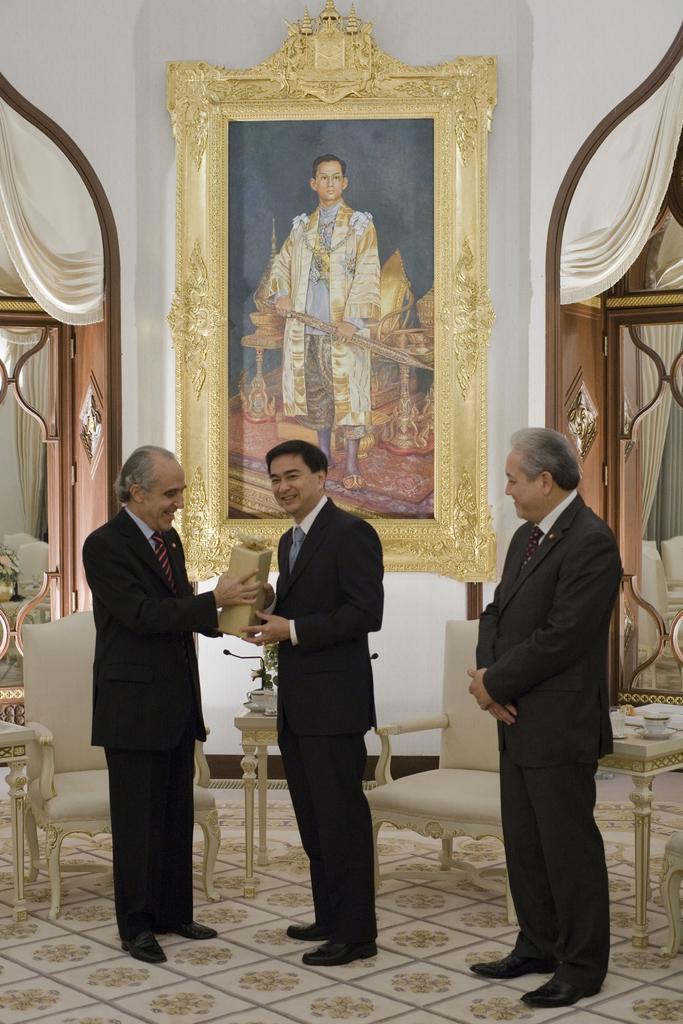Could you give a brief overview of what you see in this image? in this picture there are three persons are standing there are chairs behind the persons ,there is a big frame of a person on the wall,there are curtains near the doors. 